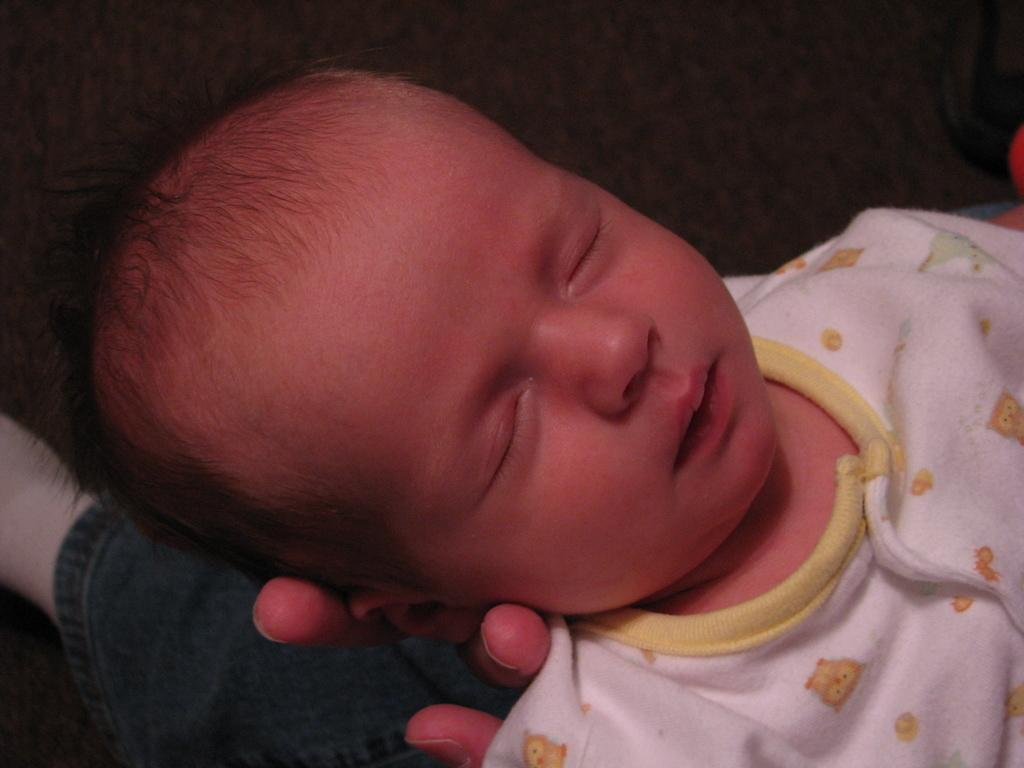Who or what is in the foreground of the image? There is a person in the foreground of the image. What is the person holding? The person is holding a boy. What type of surface is visible in the image? There is a floor visible in the image. What type of throne is visible in the image? There is no throne present in the image. Is there any rice visible in the image? There is no rice present in the image. 